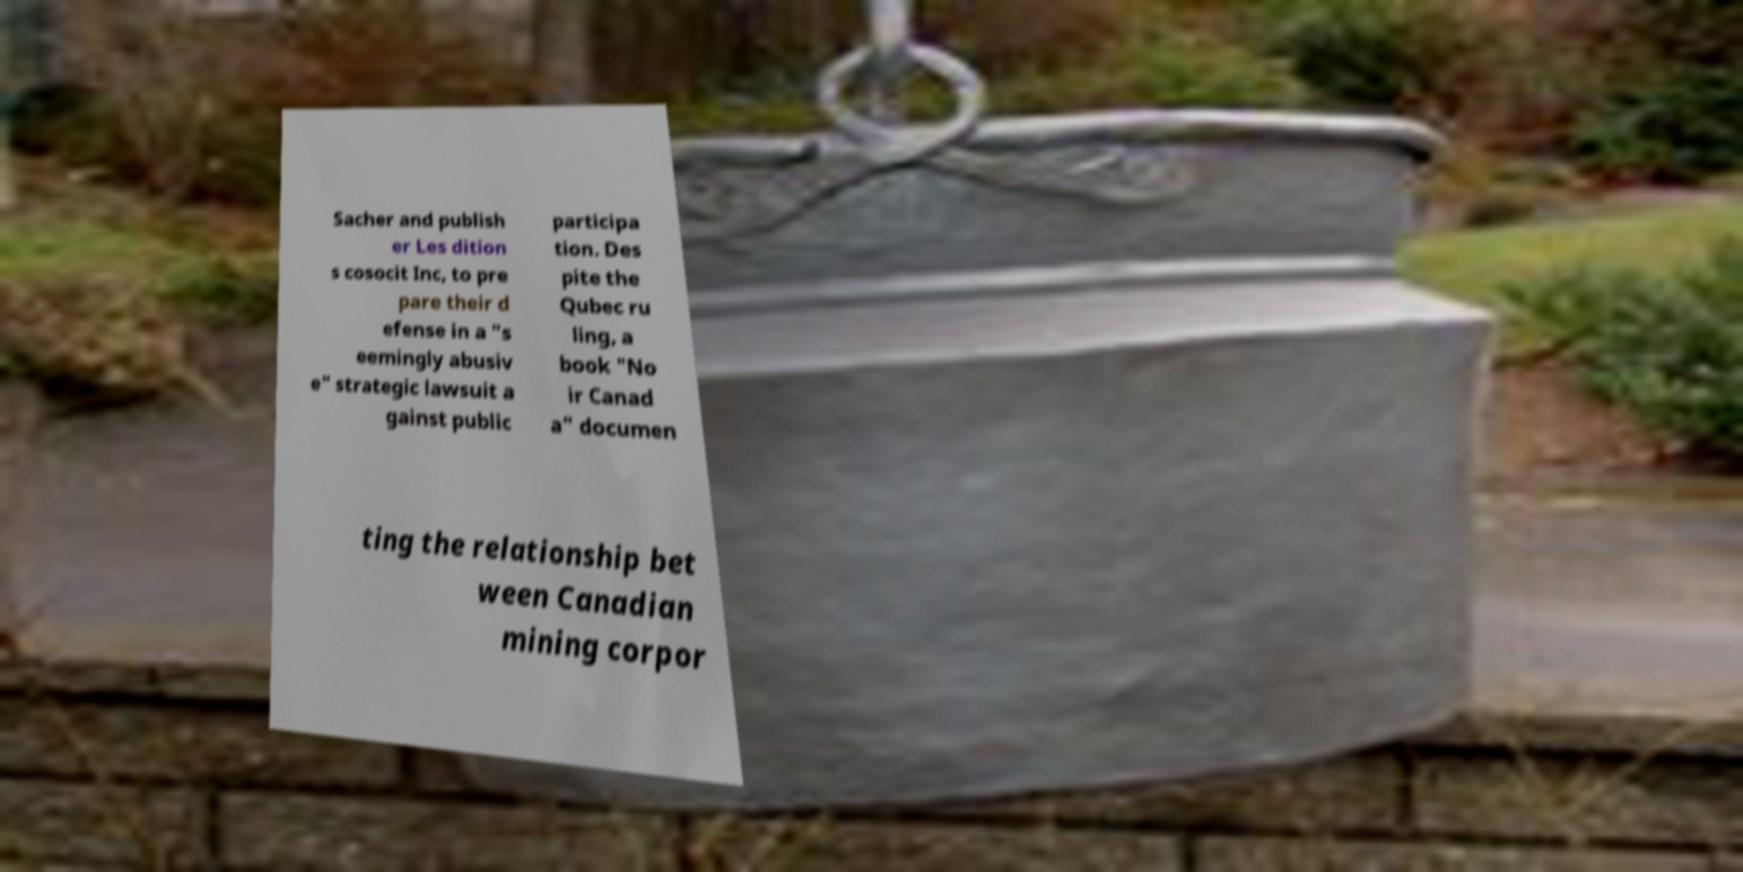Could you assist in decoding the text presented in this image and type it out clearly? Sacher and publish er Les dition s cosocit Inc, to pre pare their d efense in a "s eemingly abusiv e" strategic lawsuit a gainst public participa tion. Des pite the Qubec ru ling, a book "No ir Canad a" documen ting the relationship bet ween Canadian mining corpor 